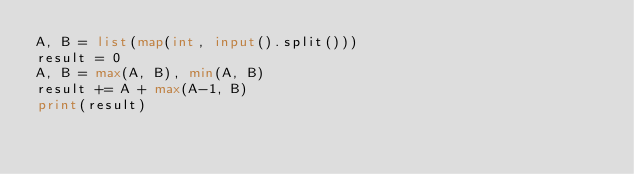Convert code to text. <code><loc_0><loc_0><loc_500><loc_500><_Python_>A, B = list(map(int, input().split()))
result = 0
A, B = max(A, B), min(A, B)
result += A + max(A-1, B)
print(result)</code> 